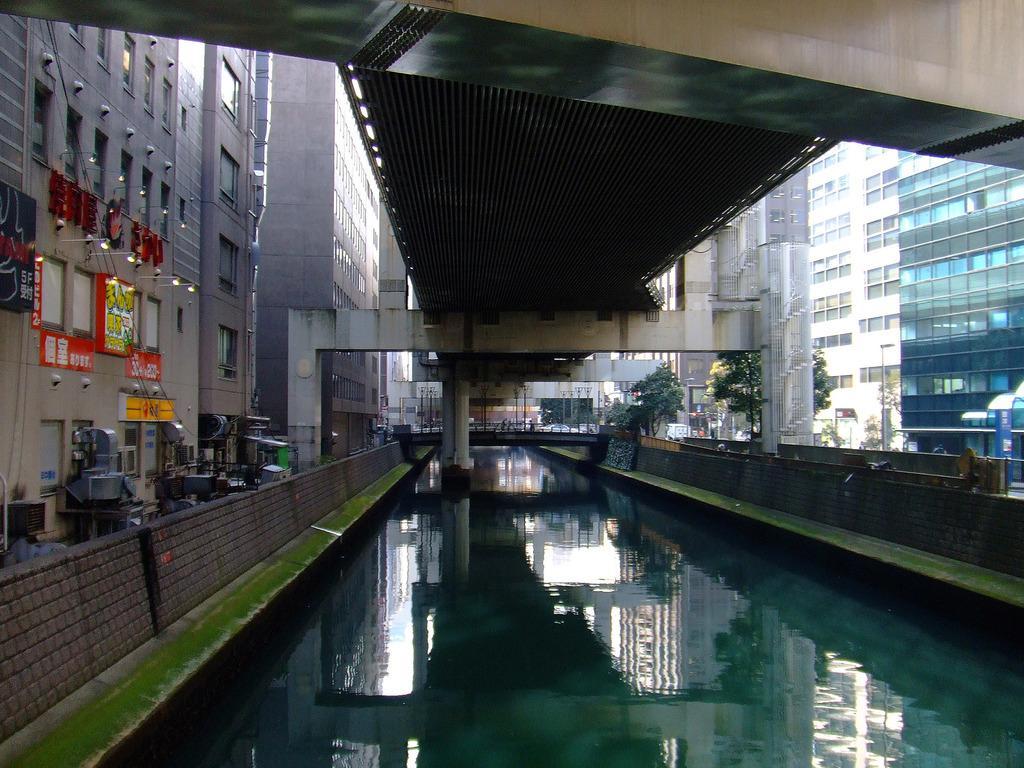Describe this image in one or two sentences. In the image we can see there are building and these are the windows of the buildings. Here we can see the bridge, pillar and the posters. We can even see lights, trees and water. 